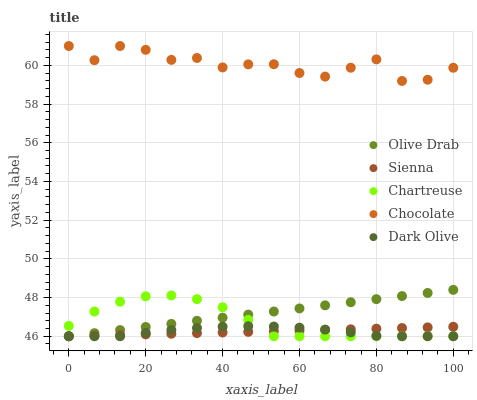Does Dark Olive have the minimum area under the curve?
Answer yes or no. Yes. Does Chocolate have the maximum area under the curve?
Answer yes or no. Yes. Does Chartreuse have the minimum area under the curve?
Answer yes or no. No. Does Chartreuse have the maximum area under the curve?
Answer yes or no. No. Is Olive Drab the smoothest?
Answer yes or no. Yes. Is Chocolate the roughest?
Answer yes or no. Yes. Is Chartreuse the smoothest?
Answer yes or no. No. Is Chartreuse the roughest?
Answer yes or no. No. Does Sienna have the lowest value?
Answer yes or no. Yes. Does Chocolate have the lowest value?
Answer yes or no. No. Does Chocolate have the highest value?
Answer yes or no. Yes. Does Chartreuse have the highest value?
Answer yes or no. No. Is Chartreuse less than Chocolate?
Answer yes or no. Yes. Is Chocolate greater than Chartreuse?
Answer yes or no. Yes. Does Olive Drab intersect Sienna?
Answer yes or no. Yes. Is Olive Drab less than Sienna?
Answer yes or no. No. Is Olive Drab greater than Sienna?
Answer yes or no. No. Does Chartreuse intersect Chocolate?
Answer yes or no. No. 